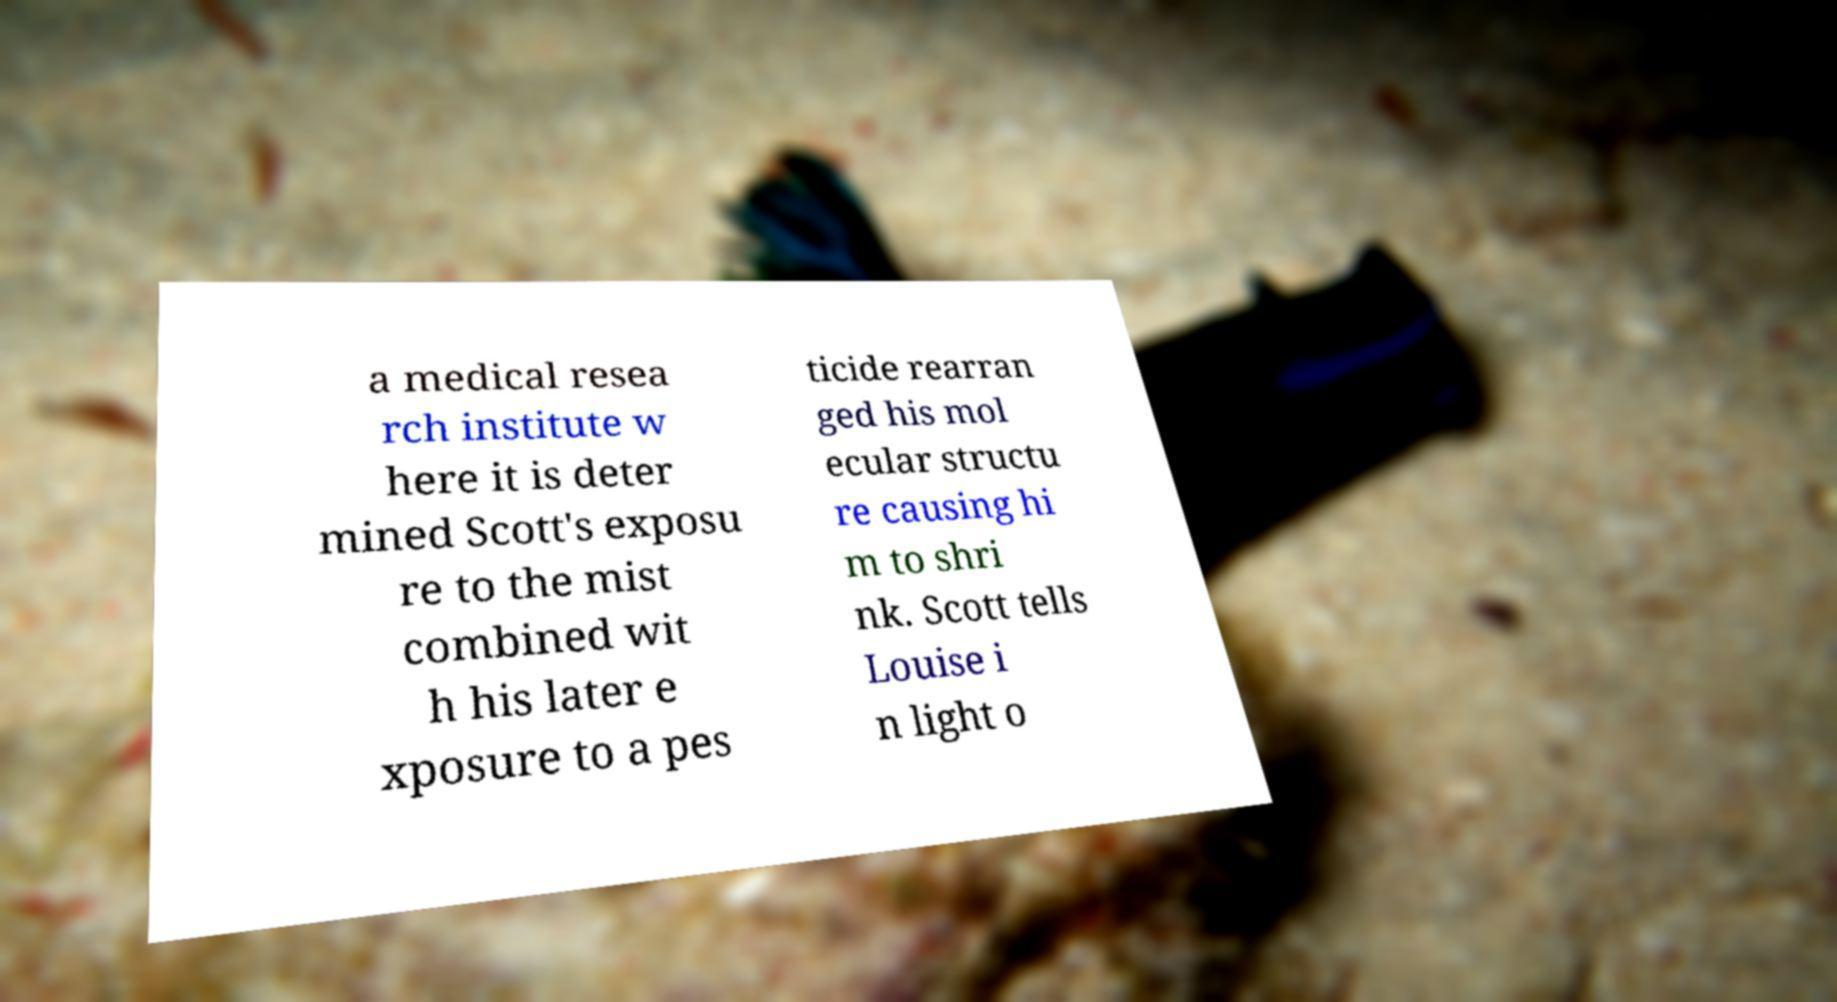Please read and relay the text visible in this image. What does it say? a medical resea rch institute w here it is deter mined Scott's exposu re to the mist combined wit h his later e xposure to a pes ticide rearran ged his mol ecular structu re causing hi m to shri nk. Scott tells Louise i n light o 